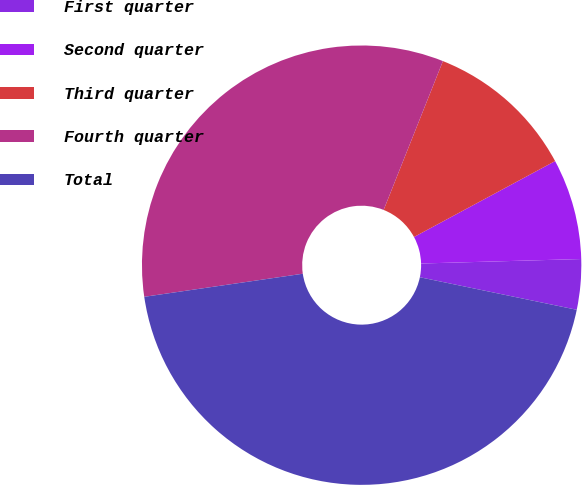<chart> <loc_0><loc_0><loc_500><loc_500><pie_chart><fcel>First quarter<fcel>Second quarter<fcel>Third quarter<fcel>Fourth quarter<fcel>Total<nl><fcel>3.7%<fcel>7.41%<fcel>11.11%<fcel>33.33%<fcel>44.44%<nl></chart> 